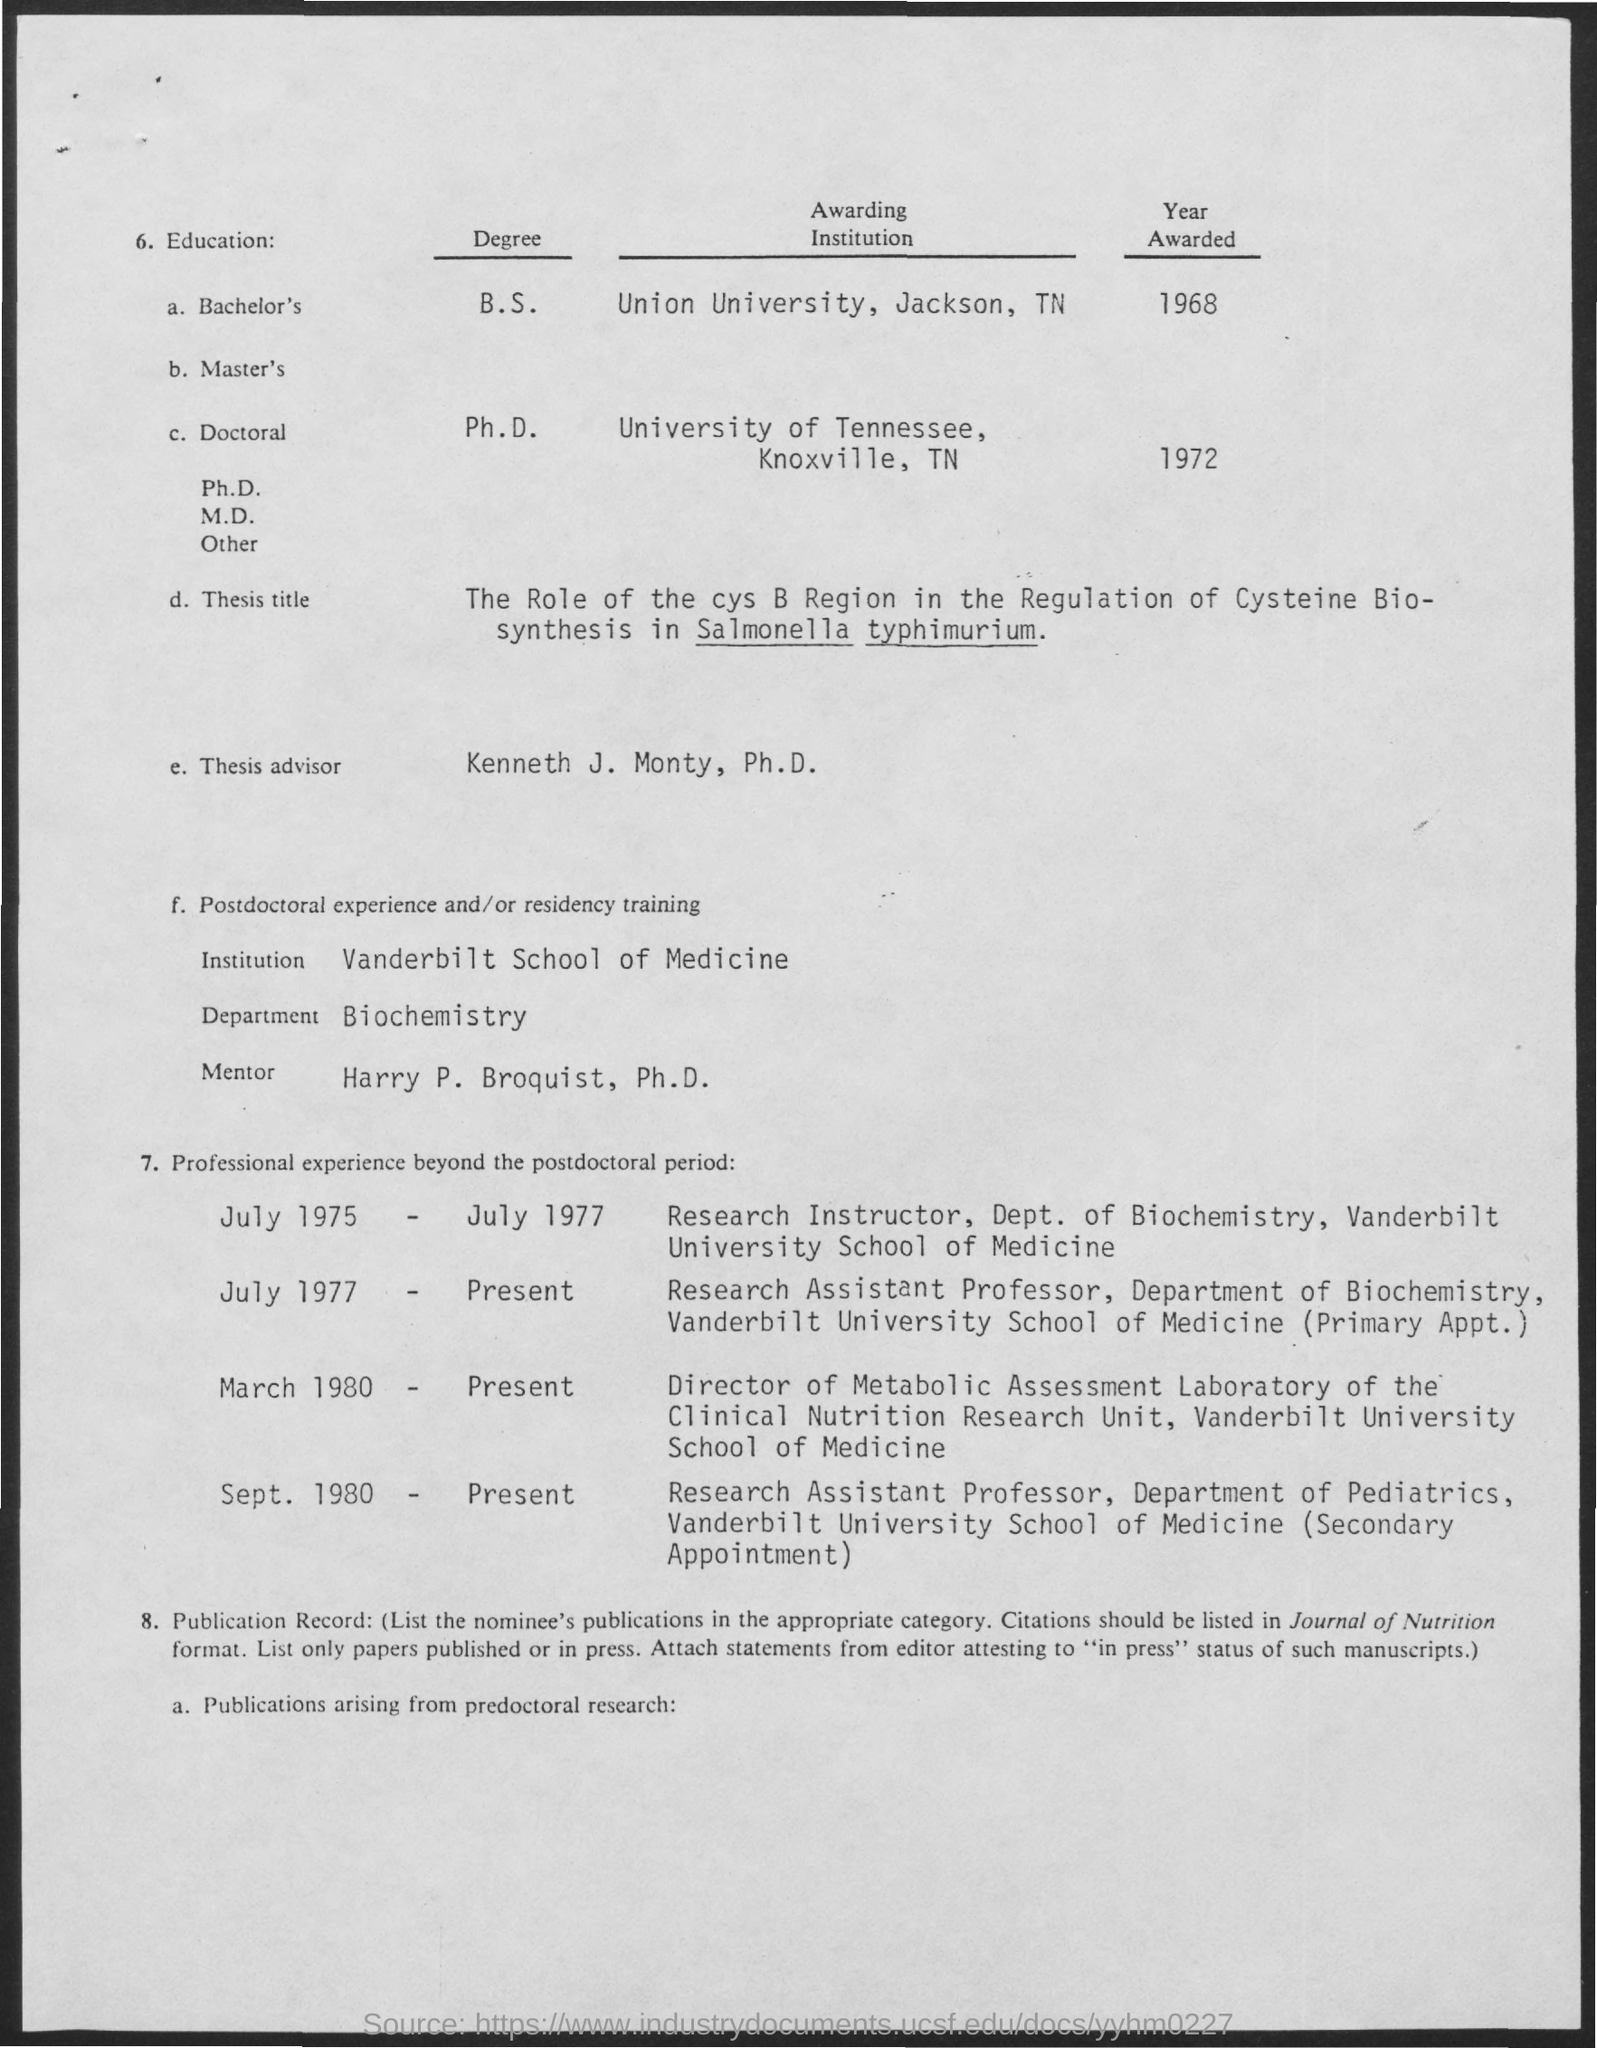What is the name of the department mentioned in the given form ?
Ensure brevity in your answer.  BIOCHEMISTRY. What is the name of thesis advisor mentioned ?
Make the answer very short. KENNETH J. MONTY. What is the name of the institution mentioned ?
Give a very brief answer. VANDERBILT SCHOOL OF MEDICINE. What is the name of the mentor mentioned?
Provide a short and direct response. HARRY P. BROQUIST. In which year the b.s. degree was awarded ?
Provide a short and direct response. 1968. In which year the degree of ph.d. was awarded ?
Give a very brief answer. 1972. What is the name of awarding institution for the degree of ph.d ?
Offer a very short reply. UNIVERSITY OF TENNESSEE. 